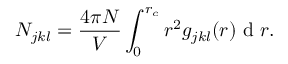<formula> <loc_0><loc_0><loc_500><loc_500>N _ { j k l } = \frac { 4 \pi N } { V } \int _ { 0 } ^ { r _ { c } } r ^ { 2 } g _ { j k l } ( r ) d r .</formula> 